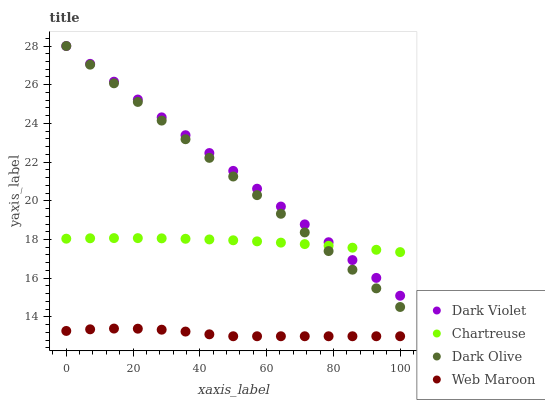Does Web Maroon have the minimum area under the curve?
Answer yes or no. Yes. Does Dark Violet have the maximum area under the curve?
Answer yes or no. Yes. Does Dark Olive have the minimum area under the curve?
Answer yes or no. No. Does Dark Olive have the maximum area under the curve?
Answer yes or no. No. Is Dark Violet the smoothest?
Answer yes or no. Yes. Is Web Maroon the roughest?
Answer yes or no. Yes. Is Dark Olive the smoothest?
Answer yes or no. No. Is Dark Olive the roughest?
Answer yes or no. No. Does Web Maroon have the lowest value?
Answer yes or no. Yes. Does Dark Olive have the lowest value?
Answer yes or no. No. Does Dark Violet have the highest value?
Answer yes or no. Yes. Does Web Maroon have the highest value?
Answer yes or no. No. Is Web Maroon less than Dark Olive?
Answer yes or no. Yes. Is Chartreuse greater than Web Maroon?
Answer yes or no. Yes. Does Chartreuse intersect Dark Olive?
Answer yes or no. Yes. Is Chartreuse less than Dark Olive?
Answer yes or no. No. Is Chartreuse greater than Dark Olive?
Answer yes or no. No. Does Web Maroon intersect Dark Olive?
Answer yes or no. No. 